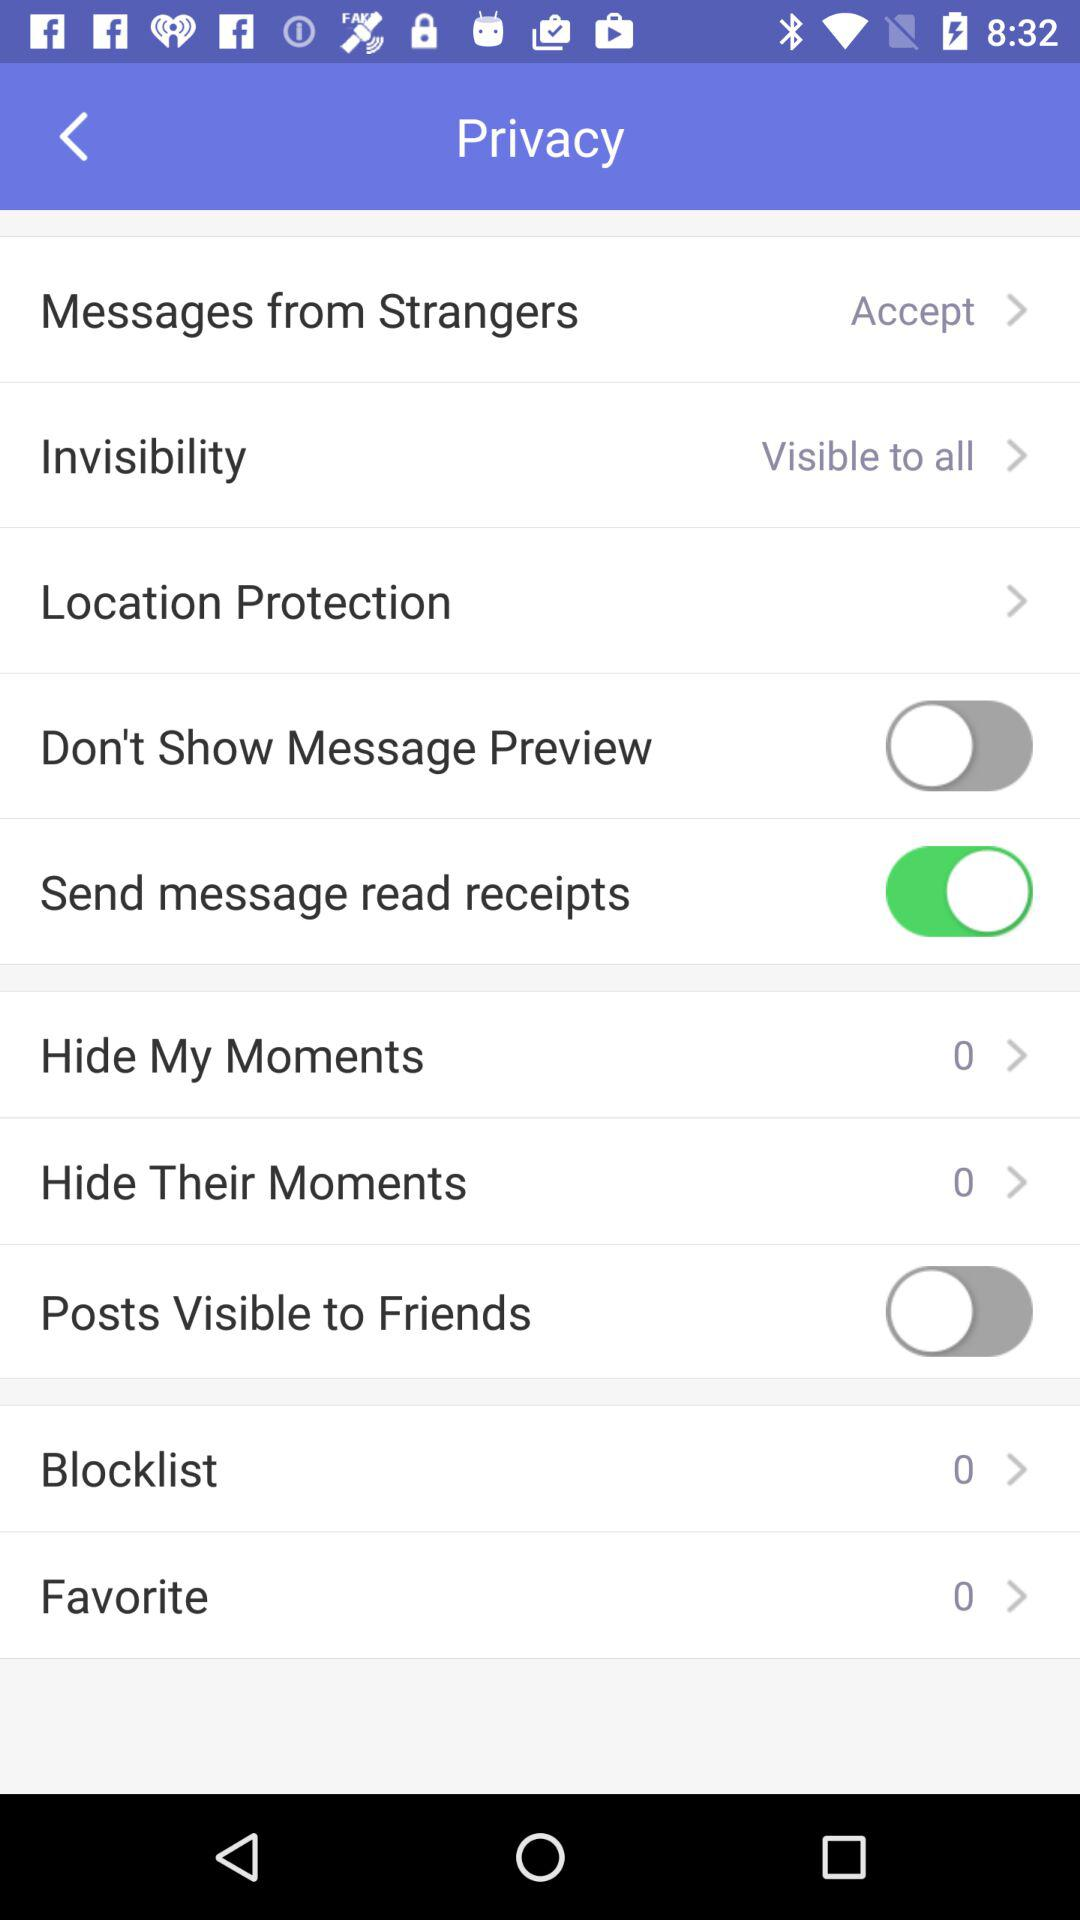What is the count for the blocklist? The count is 0. 